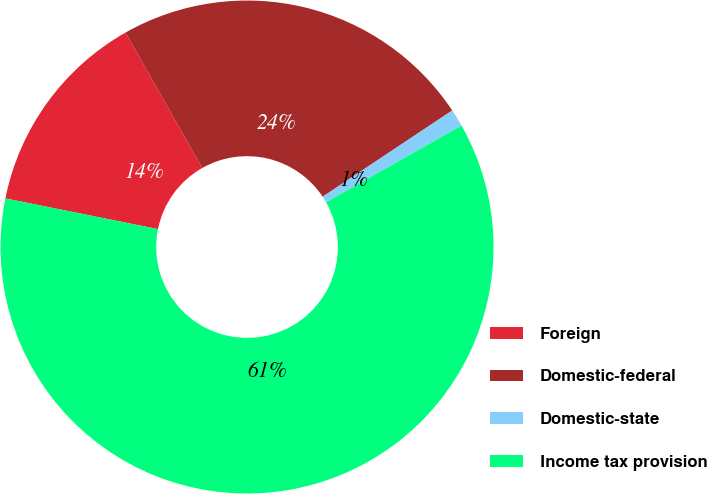Convert chart to OTSL. <chart><loc_0><loc_0><loc_500><loc_500><pie_chart><fcel>Foreign<fcel>Domestic-federal<fcel>Domestic-state<fcel>Income tax provision<nl><fcel>13.64%<fcel>23.86%<fcel>1.14%<fcel>61.36%<nl></chart> 